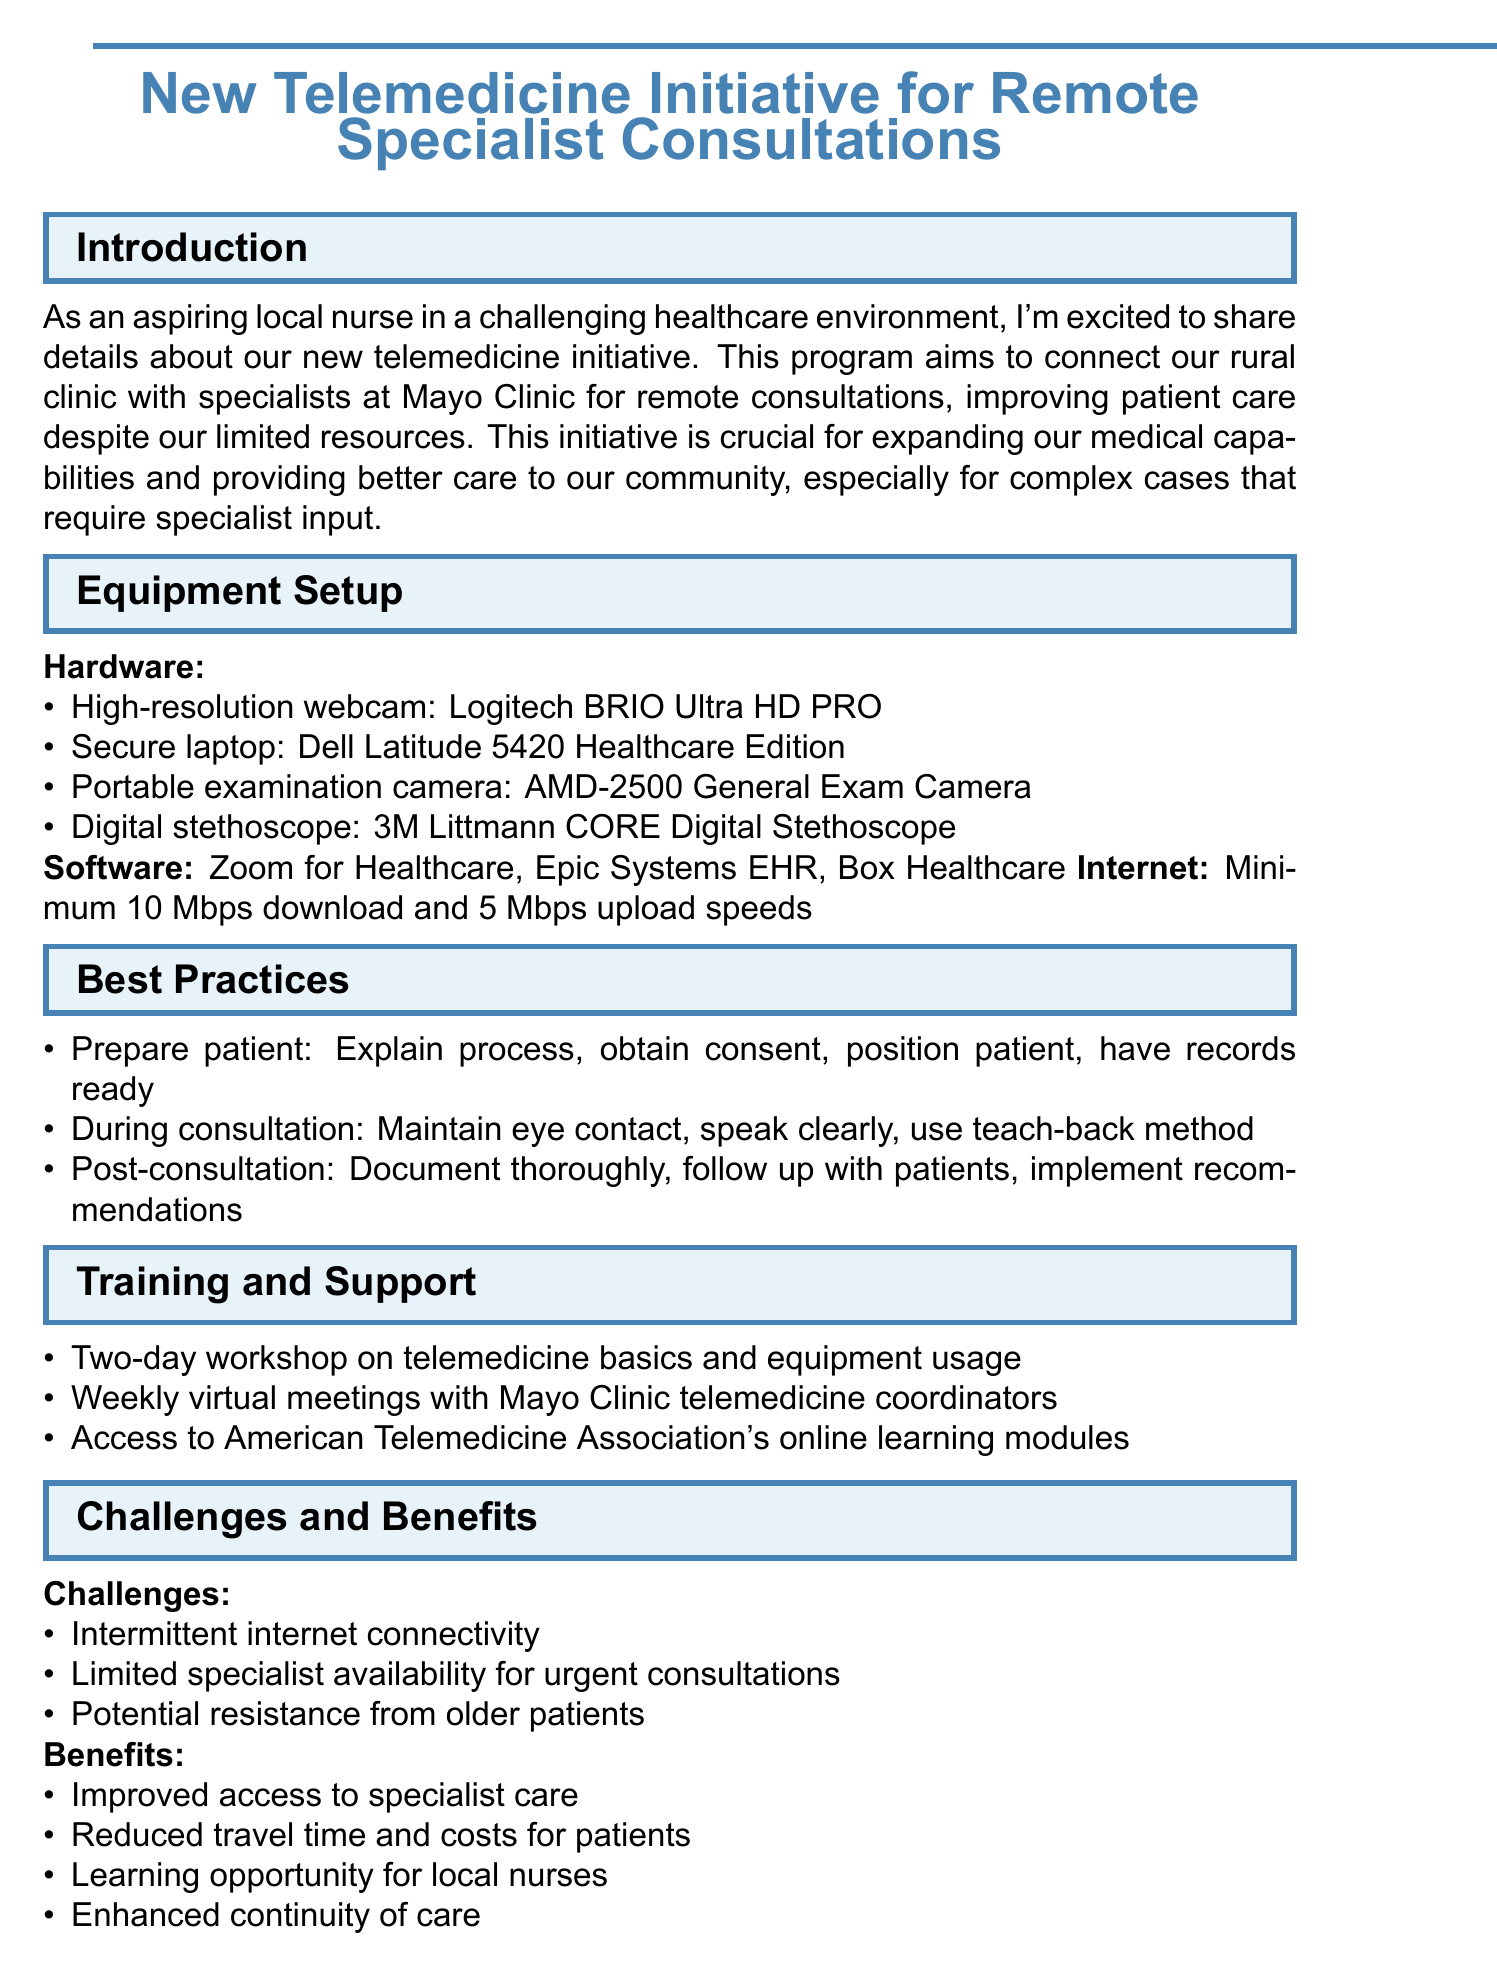What is the title of the memo? The title of the memo is stated at the beginning, which introduces the telemedicine initiative for remote consultations.
Answer: New Telemedicine Initiative for Remote Specialist Consultations What two companies are mentioned in relation to the telemedicine initiative? The memo highlights the collaboration between our rural clinic and a renowned healthcare institution for specialist consultations.
Answer: Mayo Clinic What is the minimum required download speed for internet? The document specifies performance standards for internet connection to ensure effective consultations.
Answer: Minimum 10 Mbps How long is the initial training workshop? The memo outlines the schedule for training, which is crucial for understanding the new equipment and procedures.
Answer: Two-day What should be documented thoroughly after a consultation? The memo emphasizes accountability and keeping accurate records in patient care following a specialist consultation.
Answer: Consultation What method is recommended during consultations to ensure patient understanding? The document suggests a specific technique to verify that patients comprehend the information provided during remote consultations.
Answer: Teach-back method What is one challenge mentioned in the document? The memo lists obstacles that may hinder the effectiveness of the telemedicine program, particularly in rural settings.
Answer: Intermittent internet connectivity What is one benefit of the telemedicine initiative stated in the memo? The document outlines positive outcomes expected from the new program that will impact care delivery for patients.
Answer: Improved access to specialist care 